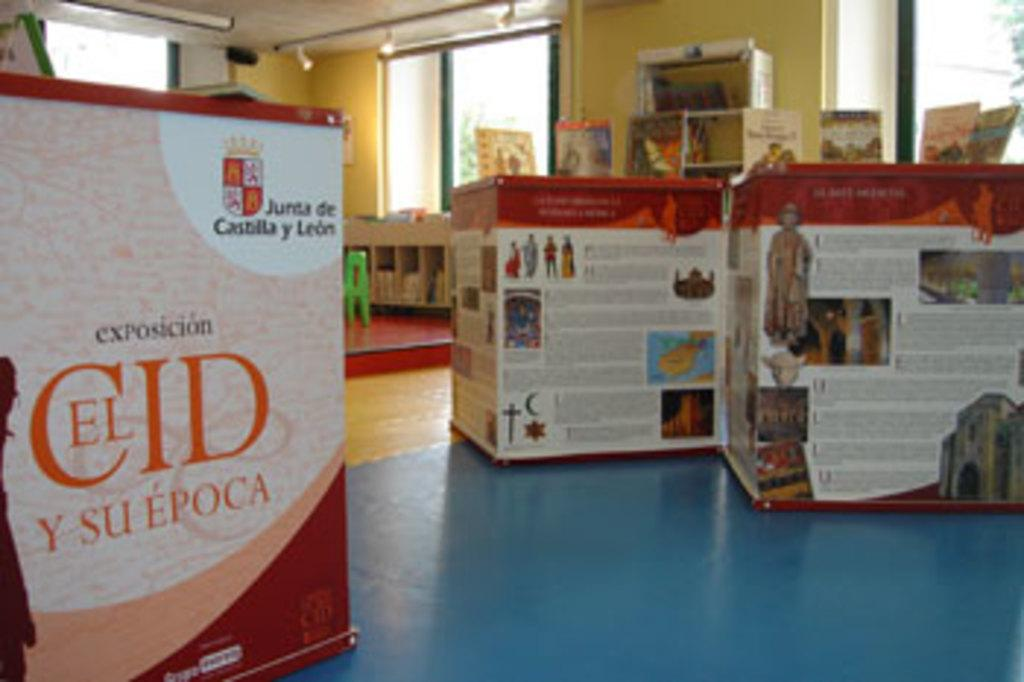What type of objects can be seen in the image? There are boxes, boards, windows, and lights in the image. Can you describe the other objects present in the image? There are other objects in the image, but their specific nature is not mentioned in the provided facts. What might be the purpose of the windows in the image? The windows in the image might provide natural light or a view of the surroundings. What type of illumination is present in the image? There are lights in the image, which might provide artificial illumination. How many dogs are visible in the image? There are no dogs present in the image. What is the fifth object in the image? The provided facts do not mention a fifth object in the image. 